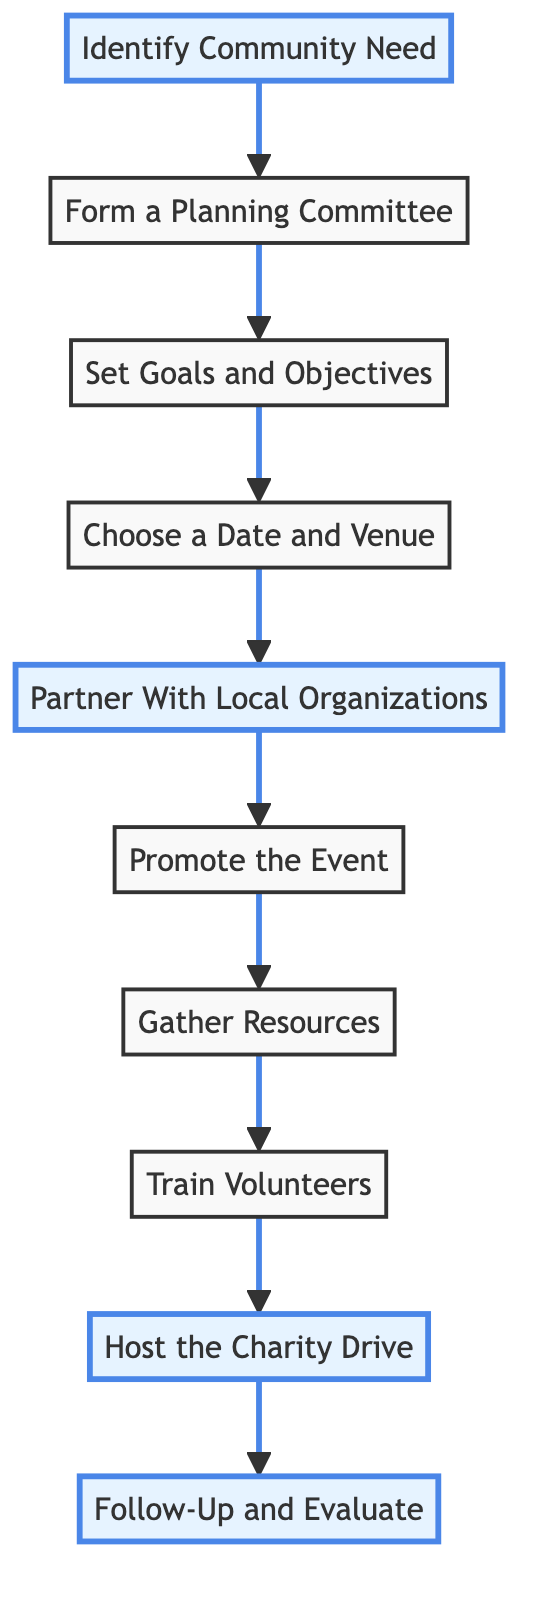What is the first step in organizing a local charity drive? The first step is "Identify Community Need", as indicated by the starting node in the diagram. It is the first action that leads to the subsequent steps in the process.
Answer: Identify Community Need How many total steps are there in the charity drive process? By counting the nodes in the diagram, there are 10 distinct steps listed from the start to the finish of organizing a charity drive.
Answer: 10 What is the last step listed in the diagram? The final step is "Follow-Up and Evaluate", which is at the end of the flow, indicating it is the last action performed after hosting the charity drive.
Answer: Follow-Up and Evaluate Which two steps directly follow "Choose a Date and Venue"? The steps that directly follow "Choose a Date and Venue" are "Partner With Local Organizations" and "Promote the Event". This can be seen by tracing the arrows sequentially from "Choose a Date and Venue" on the diagram.
Answer: Partner With Local Organizations, Promote the Event What role do local organizations play in the charity drive? The step "Partner With Local Organizations" signifies that collaborating with these groups helps to gather support and resources for the charity drive, showing their important role in the process.
Answer: Gather support and resources How many highlighted steps are there in the diagram? The diagram highlights 4 specific steps: "Identify Community Need," "Partner With Local Organizations," "Host the Charity Drive," and "Follow-Up and Evaluate," which can be identified visually by the color and style associated with these nodes.
Answer: 4 What is the purpose of training volunteers? The step "Train Volunteers" specifies that this step provides orientation and training, ensuring volunteers understand their roles and responsibilities during the charity drive, which is essential for smooth execution.
Answer: Understand roles and responsibilities In which order do the steps take place following "Set Goals and Objectives"? The order of the steps following "Set Goals and Objectives" is "Choose a Date and Venue," "Partner With Local Organizations," "Promote the Event," and so on, indicating the sequential flow as per the diagram's connections.
Answer: Choose a Date and Venue, Partner With Local Organizations, Promote the Event, Gather Resources, Train Volunteers, Host the Charity Drive, Follow-Up and Evaluate 